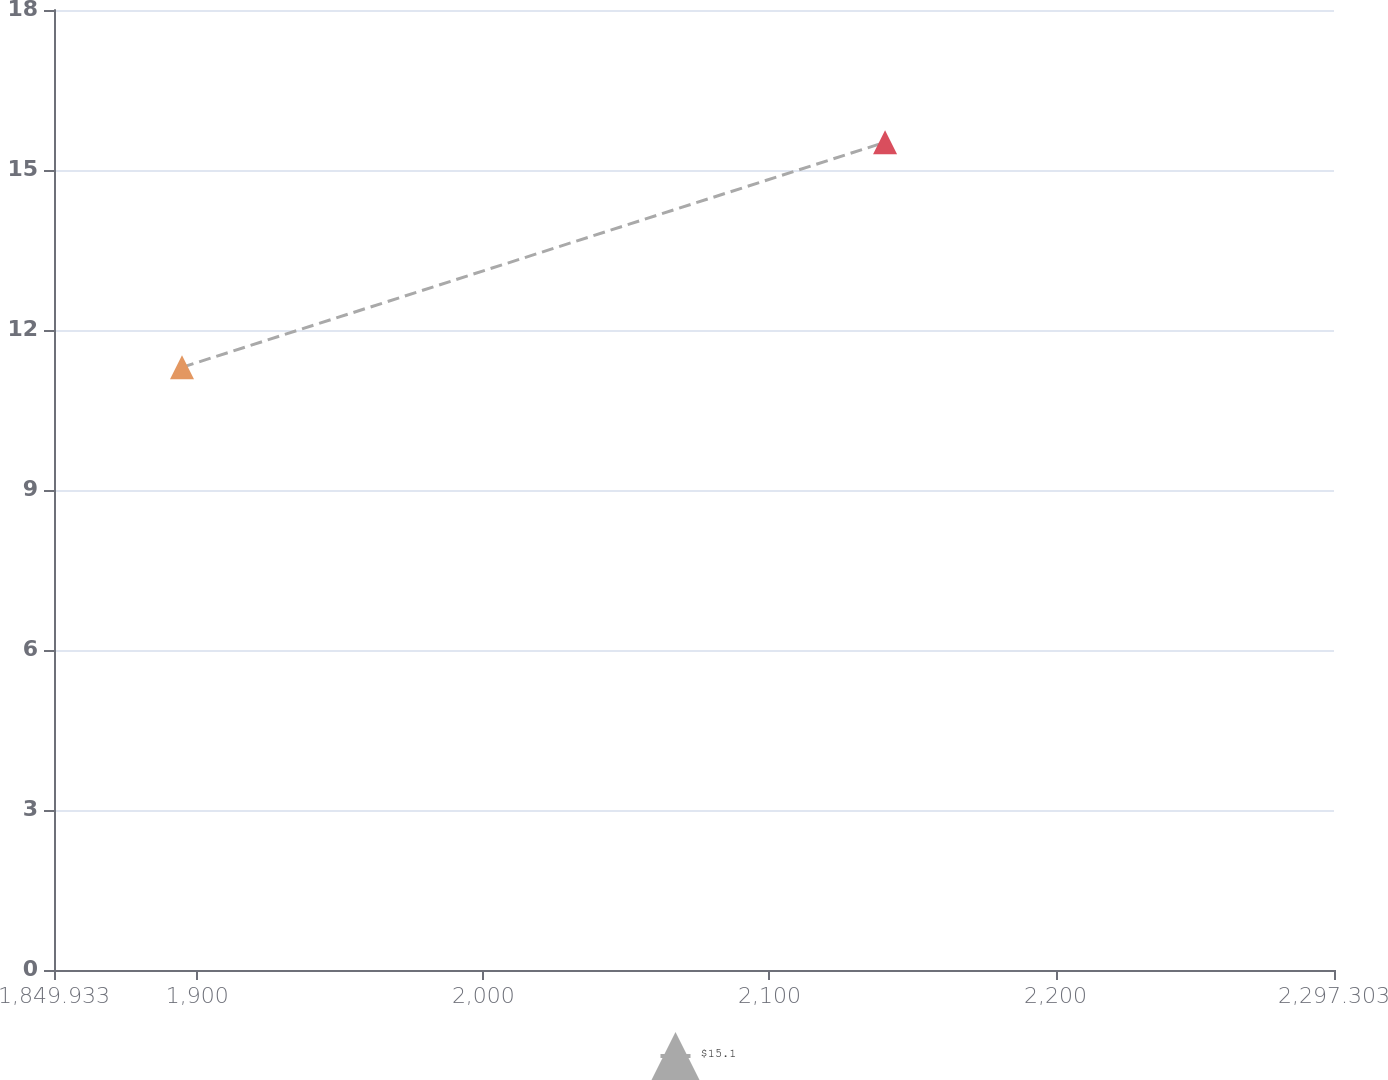Convert chart. <chart><loc_0><loc_0><loc_500><loc_500><line_chart><ecel><fcel>$15.1<nl><fcel>1894.67<fcel>11.3<nl><fcel>2140.39<fcel>15.52<nl><fcel>2301.18<fcel>5.38<nl><fcel>2342.04<fcel>1.49<nl></chart> 